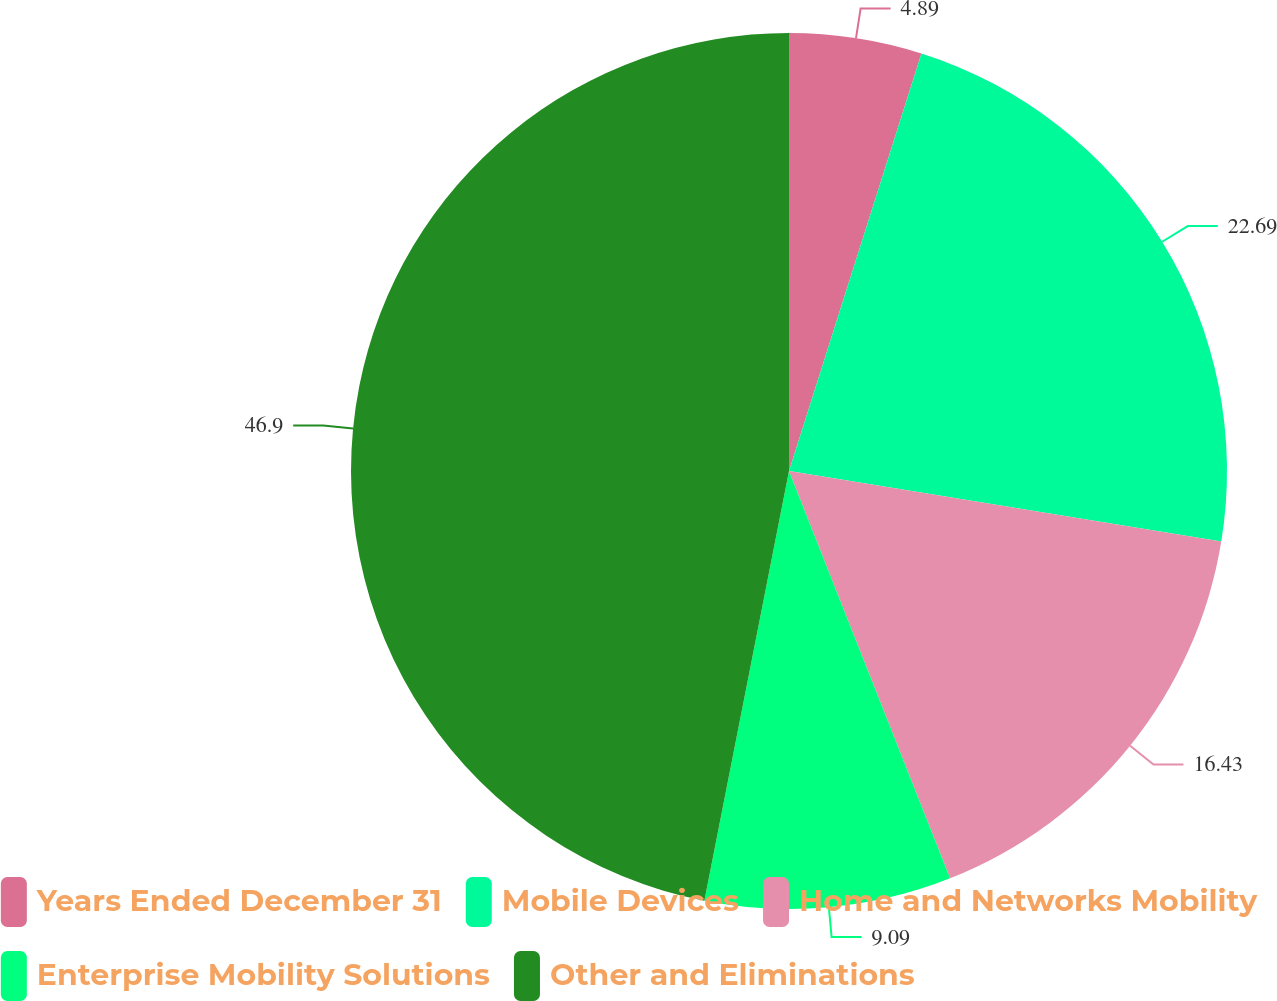<chart> <loc_0><loc_0><loc_500><loc_500><pie_chart><fcel>Years Ended December 31<fcel>Mobile Devices<fcel>Home and Networks Mobility<fcel>Enterprise Mobility Solutions<fcel>Other and Eliminations<nl><fcel>4.89%<fcel>22.69%<fcel>16.43%<fcel>9.09%<fcel>46.91%<nl></chart> 